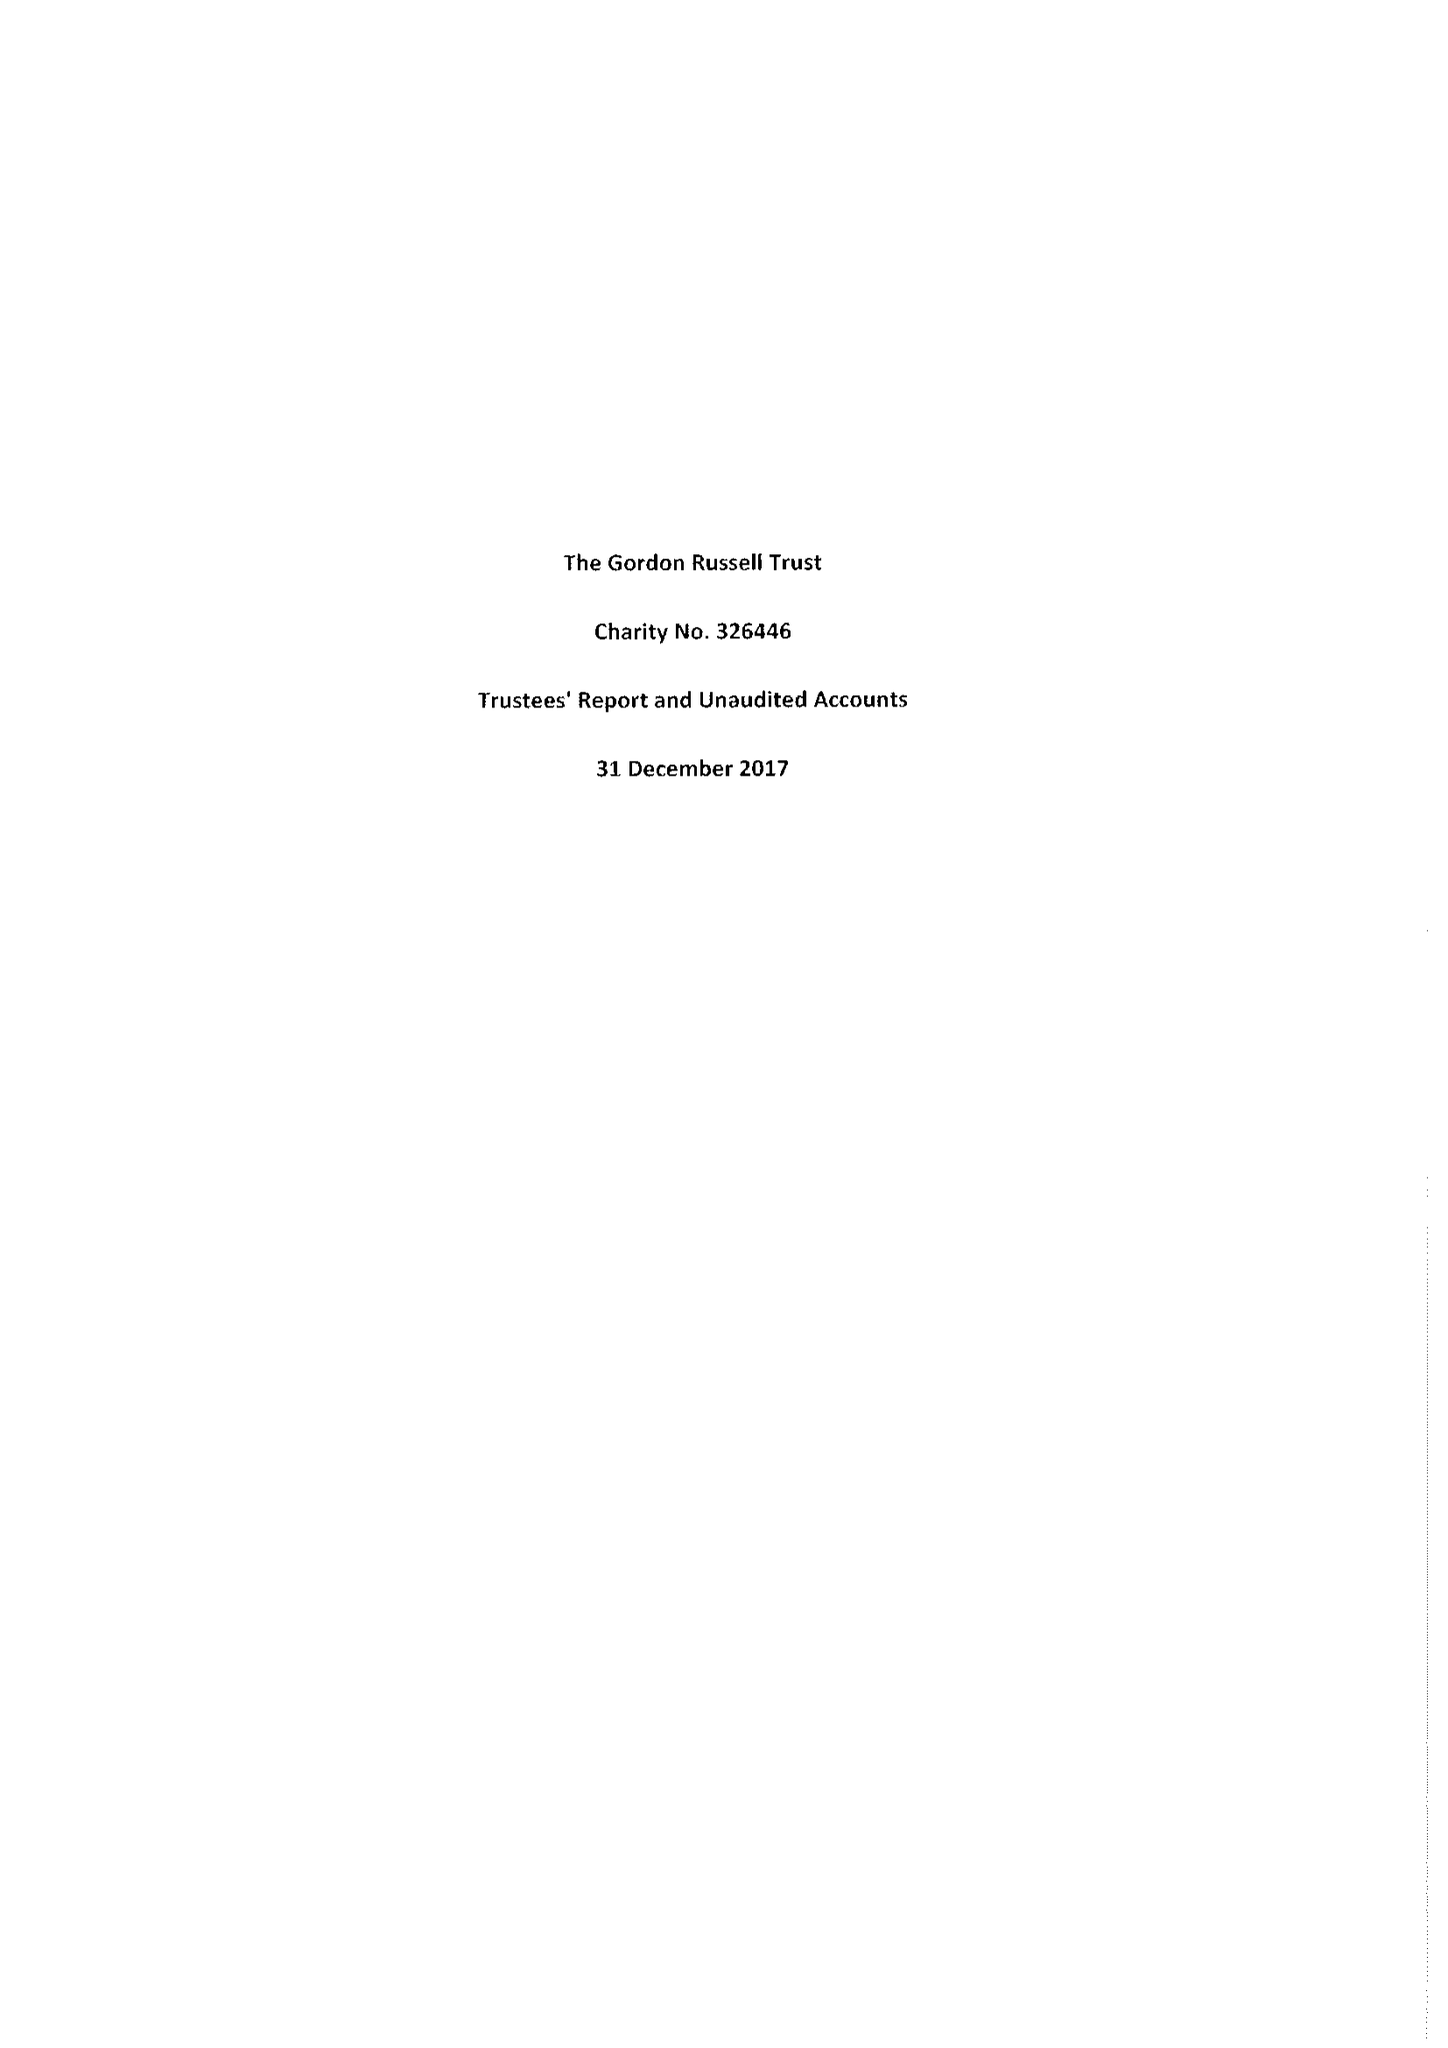What is the value for the address__post_town?
Answer the question using a single word or phrase. BROADWAY 